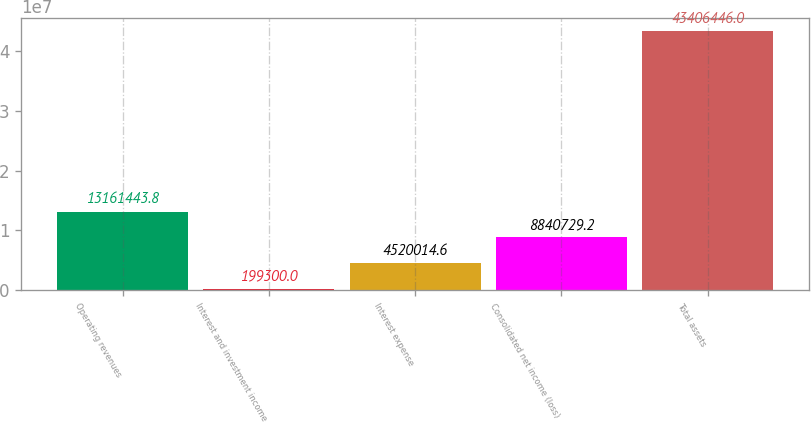Convert chart to OTSL. <chart><loc_0><loc_0><loc_500><loc_500><bar_chart><fcel>Operating revenues<fcel>Interest and investment income<fcel>Interest expense<fcel>Consolidated net income (loss)<fcel>Total assets<nl><fcel>1.31614e+07<fcel>199300<fcel>4.52001e+06<fcel>8.84073e+06<fcel>4.34064e+07<nl></chart> 